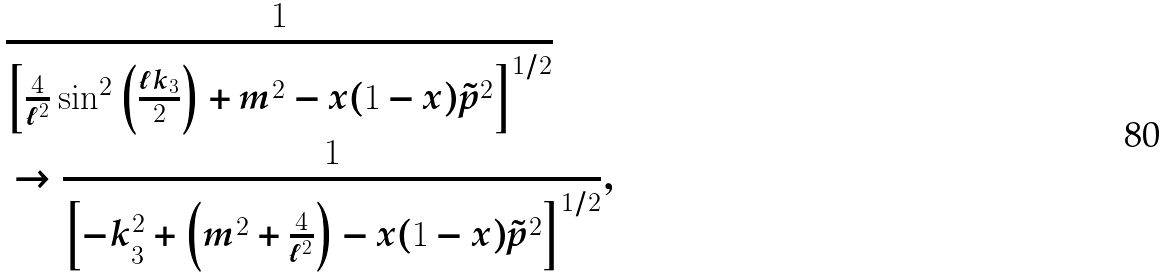Convert formula to latex. <formula><loc_0><loc_0><loc_500><loc_500>& \frac { 1 } { \left [ \frac { 4 } { \ell ^ { 2 } } \sin ^ { 2 } \left ( \frac { \ell k _ { 3 } } { 2 } \right ) + m ^ { 2 } - x ( 1 - x ) \tilde { p } ^ { 2 } \right ] ^ { 1 / 2 } } \\ & \to \frac { 1 } { \left [ - k _ { 3 } ^ { 2 } + \left ( m ^ { 2 } + \frac { 4 } { \ell ^ { 2 } } \right ) - x ( 1 - x ) \tilde { p } ^ { 2 } \right ] ^ { 1 / 2 } } ,</formula> 